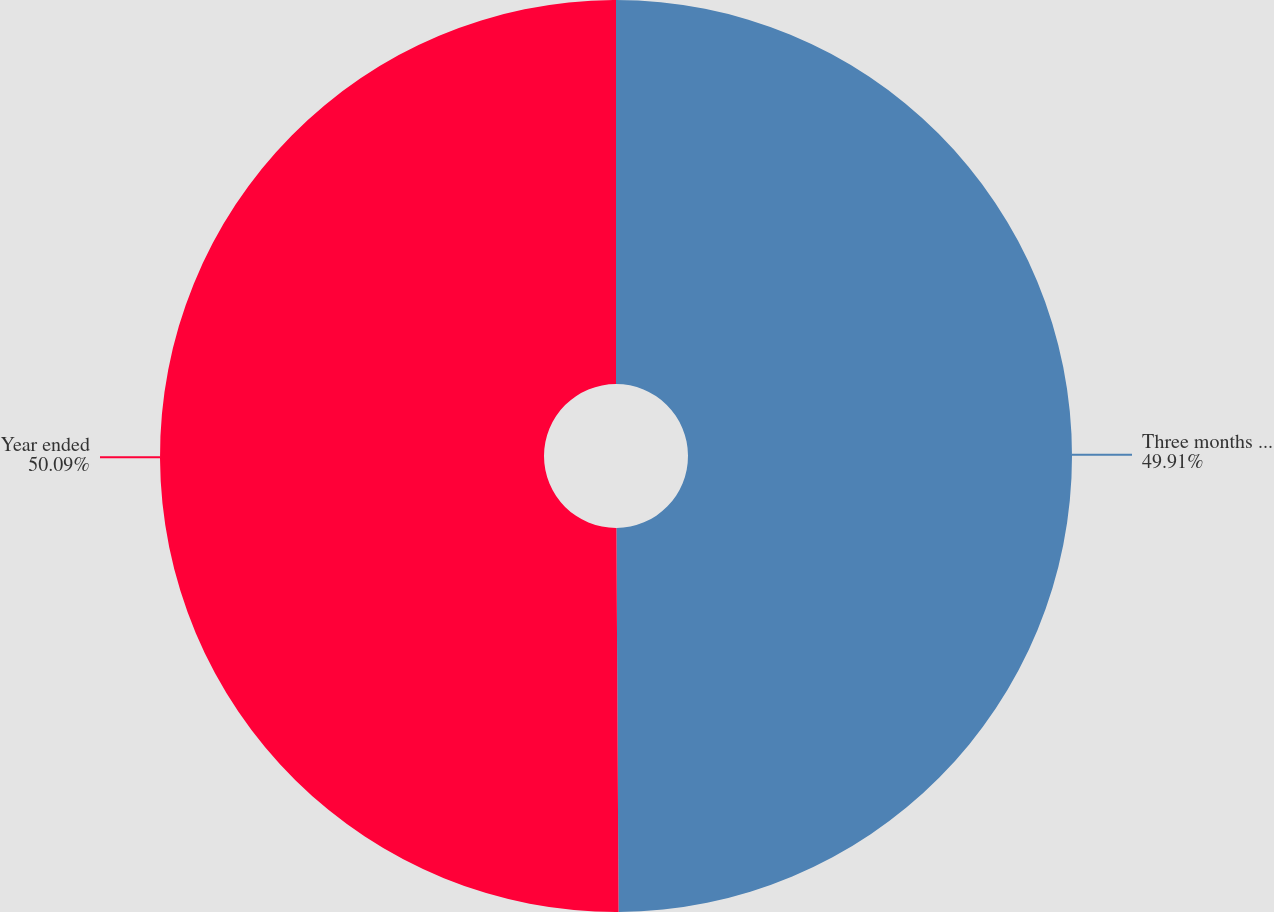Convert chart. <chart><loc_0><loc_0><loc_500><loc_500><pie_chart><fcel>Three months ended<fcel>Year ended<nl><fcel>49.91%<fcel>50.09%<nl></chart> 